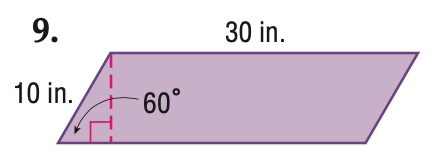Answer the mathemtical geometry problem and directly provide the correct option letter.
Question: Find the perimeter of the parallelogram. Round to the nearest tenth if necessary.
Choices: A: 60 B: 80 C: 100 D: 120 B 